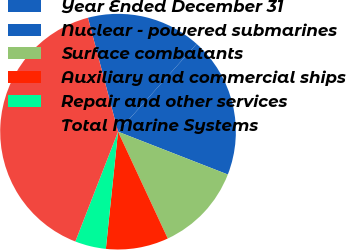Convert chart to OTSL. <chart><loc_0><loc_0><loc_500><loc_500><pie_chart><fcel>Year Ended December 31<fcel>Nuclear - powered submarines<fcel>Surface combatants<fcel>Auxiliary and commercial ships<fcel>Repair and other services<fcel>Total Marine Systems<nl><fcel>15.73%<fcel>19.3%<fcel>12.15%<fcel>8.58%<fcel>4.25%<fcel>39.99%<nl></chart> 